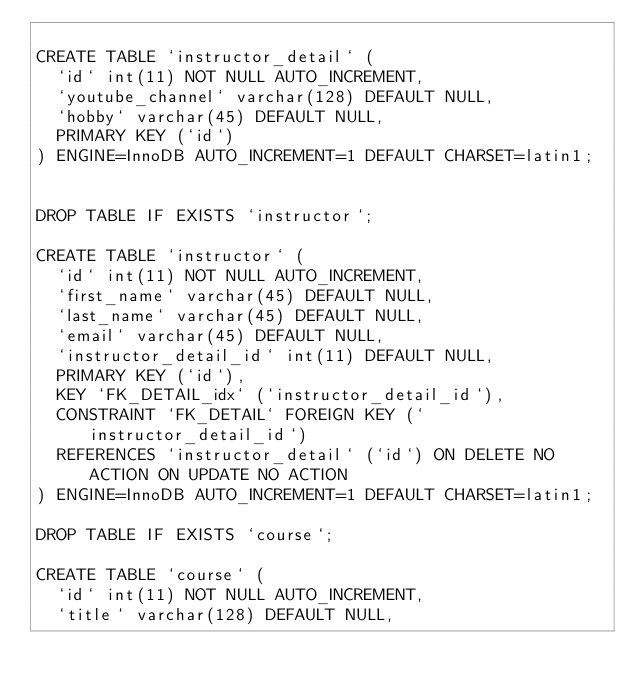<code> <loc_0><loc_0><loc_500><loc_500><_SQL_>
CREATE TABLE `instructor_detail` (
  `id` int(11) NOT NULL AUTO_INCREMENT,
  `youtube_channel` varchar(128) DEFAULT NULL,
  `hobby` varchar(45) DEFAULT NULL,
  PRIMARY KEY (`id`)
) ENGINE=InnoDB AUTO_INCREMENT=1 DEFAULT CHARSET=latin1;


DROP TABLE IF EXISTS `instructor`;

CREATE TABLE `instructor` (
  `id` int(11) NOT NULL AUTO_INCREMENT,
  `first_name` varchar(45) DEFAULT NULL,
  `last_name` varchar(45) DEFAULT NULL,
  `email` varchar(45) DEFAULT NULL,
  `instructor_detail_id` int(11) DEFAULT NULL,
  PRIMARY KEY (`id`),
  KEY `FK_DETAIL_idx` (`instructor_detail_id`),
  CONSTRAINT `FK_DETAIL` FOREIGN KEY (`instructor_detail_id`) 
  REFERENCES `instructor_detail` (`id`) ON DELETE NO ACTION ON UPDATE NO ACTION
) ENGINE=InnoDB AUTO_INCREMENT=1 DEFAULT CHARSET=latin1;

DROP TABLE IF EXISTS `course`;

CREATE TABLE `course` (
  `id` int(11) NOT NULL AUTO_INCREMENT,
  `title` varchar(128) DEFAULT NULL,</code> 